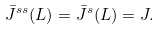Convert formula to latex. <formula><loc_0><loc_0><loc_500><loc_500>\bar { J } ^ { s s } ( L ) = \bar { J } ^ { s } ( L ) = J .</formula> 